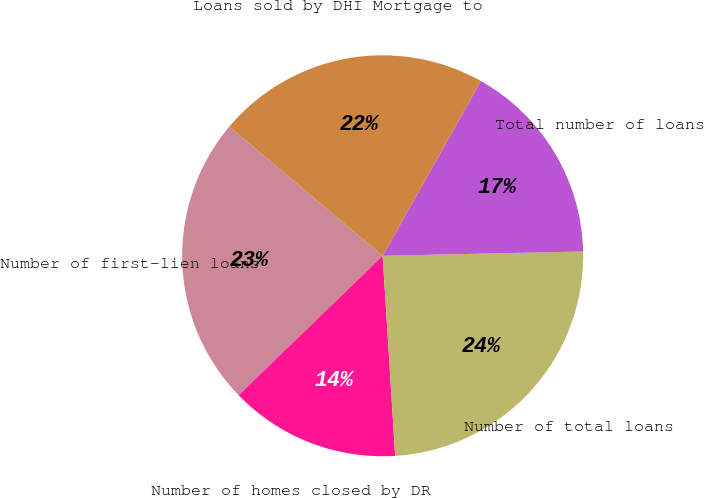Convert chart. <chart><loc_0><loc_0><loc_500><loc_500><pie_chart><fcel>Number of first-lien loans<fcel>Number of homes closed by DR<fcel>Number of total loans<fcel>Total number of loans<fcel>Loans sold by DHI Mortgage to<nl><fcel>23.38%<fcel>13.76%<fcel>24.35%<fcel>16.51%<fcel>22.01%<nl></chart> 